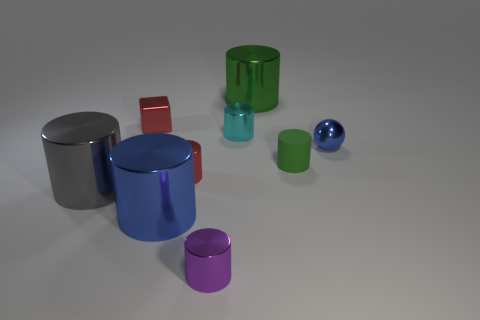Is the number of tiny blue shiny objects less than the number of large blue rubber cubes?
Your answer should be compact. No. What number of metallic objects are either large cylinders or yellow things?
Make the answer very short. 3. There is a green object on the right side of the big green thing; is there a small matte thing that is in front of it?
Your answer should be very brief. No. Are the big cylinder behind the tiny blue metal object and the large blue object made of the same material?
Offer a very short reply. Yes. How many other objects are there of the same color as the rubber object?
Keep it short and to the point. 1. Do the block and the tiny metal sphere have the same color?
Make the answer very short. No. There is a cylinder that is in front of the blue object that is in front of the small red shiny cylinder; what is its size?
Ensure brevity in your answer.  Small. Is the large cylinder behind the blue ball made of the same material as the blue thing that is on the right side of the small rubber cylinder?
Give a very brief answer. Yes. There is a cylinder that is left of the tiny red block; is it the same color as the tiny matte thing?
Ensure brevity in your answer.  No. There is a small purple metal cylinder; how many large green metal objects are in front of it?
Your answer should be very brief. 0. 